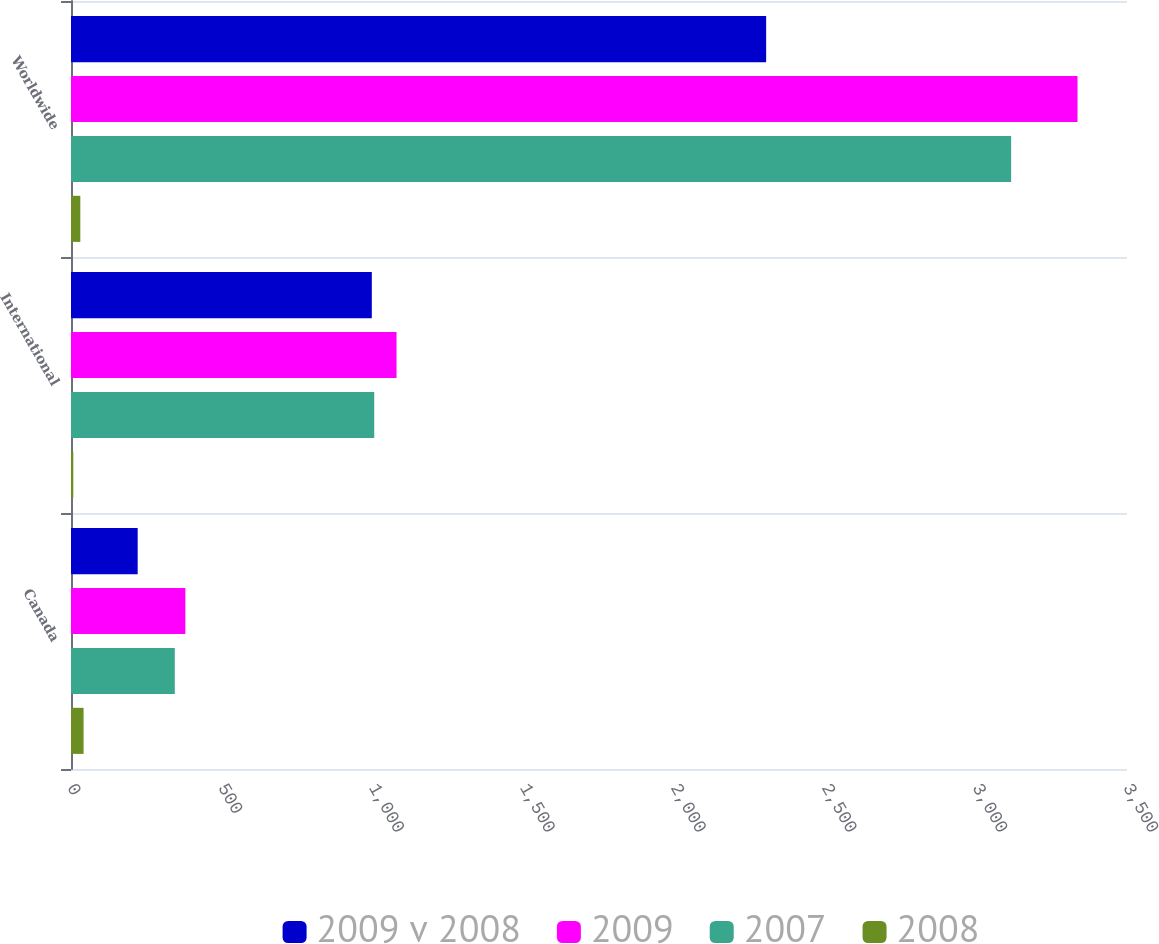Convert chart. <chart><loc_0><loc_0><loc_500><loc_500><stacked_bar_chart><ecel><fcel>Canada<fcel>International<fcel>Worldwide<nl><fcel>2009 v 2008<fcel>221<fcel>997<fcel>2304<nl><fcel>2009<fcel>379<fcel>1079<fcel>3336<nl><fcel>2007<fcel>344<fcel>1005<fcel>3116<nl><fcel>2008<fcel>41.7<fcel>7.6<fcel>30.9<nl></chart> 